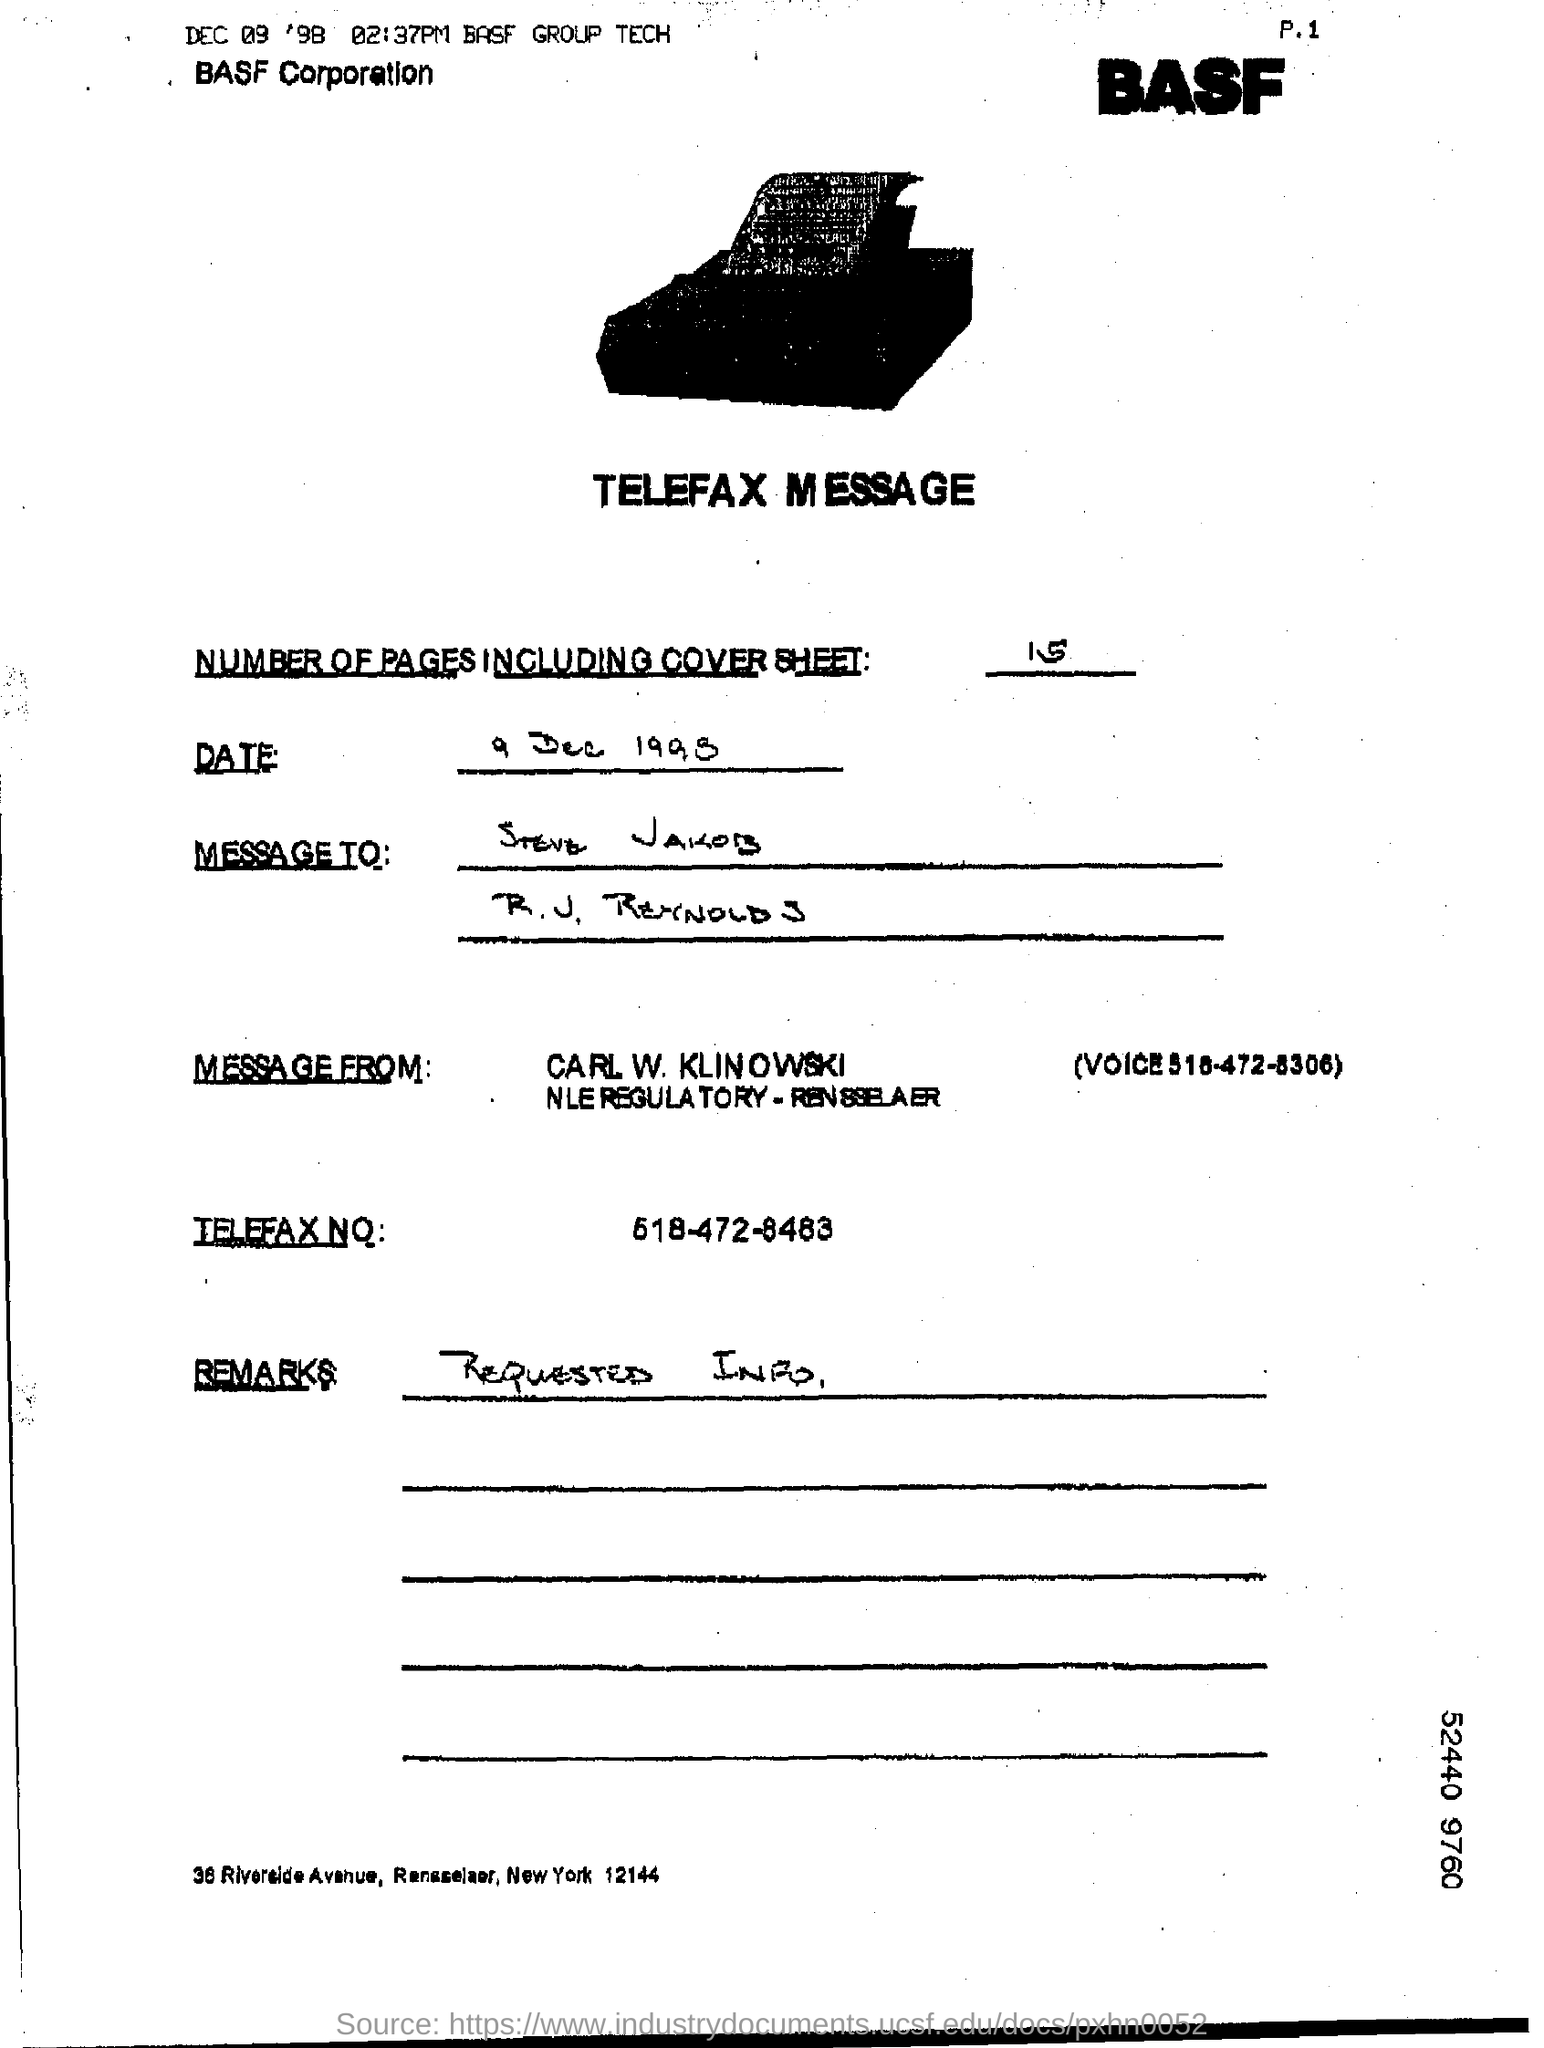List a handful of essential elements in this visual. The number of pages, including the cover sheet, is 15. The message is from Carl W. Klinowski. The telephone number is 518-472-8483. 